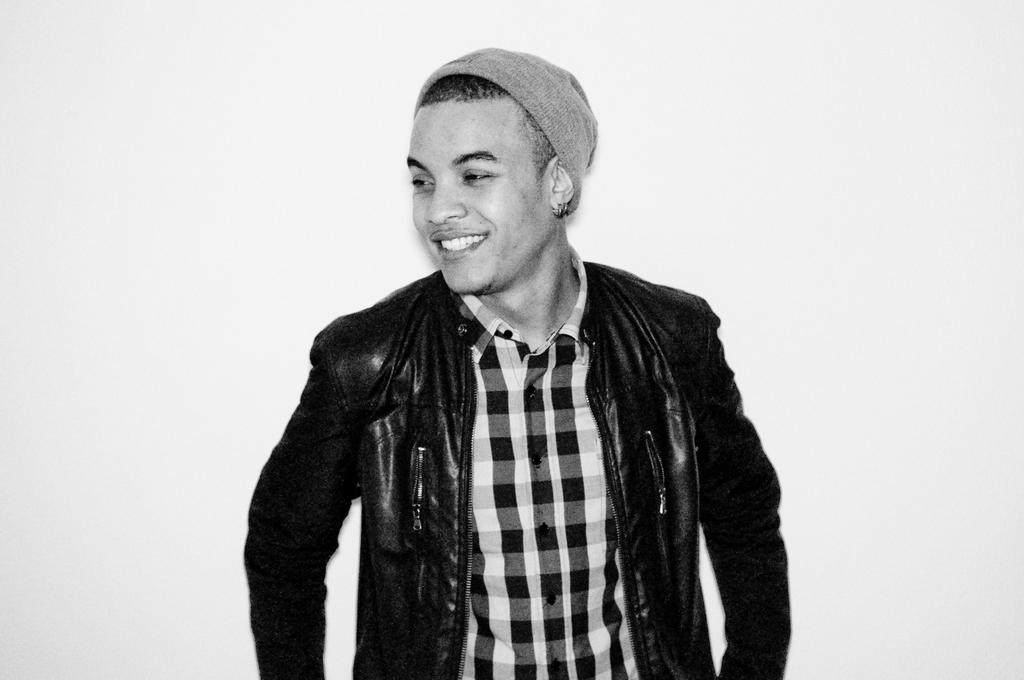What is the main subject in the foreground of the image? There is a man in the foreground of the image. What is the man wearing on his upper body? The man is wearing a coat. What is the man wearing on his head? The man is wearing a cap on his head. What is the color of the background in the image? The background of the image is white in color. How many cows are visible in the image? There are no cows present in the image. What type of patch is sewn onto the man's coat in the image? There is no patch visible on the man's coat in the image. 